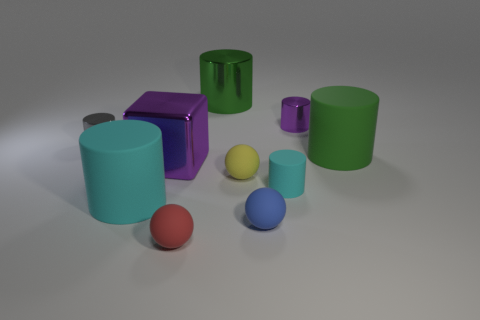Are there more green matte objects in front of the small yellow matte object than large cylinders that are in front of the green shiny cylinder?
Ensure brevity in your answer.  No. There is a metallic object that is to the right of the metal cylinder that is behind the purple object that is behind the big purple shiny block; what size is it?
Ensure brevity in your answer.  Small. Are there any other tiny matte cylinders of the same color as the small rubber cylinder?
Provide a short and direct response. No. What number of large green things are there?
Your answer should be very brief. 2. There is a big cylinder left of the metal block left of the green cylinder behind the small purple cylinder; what is it made of?
Keep it short and to the point. Rubber. Is there a small blue cylinder made of the same material as the large purple block?
Make the answer very short. No. Is the large purple cube made of the same material as the tiny blue sphere?
Provide a short and direct response. No. What number of cylinders are either cyan matte objects or small cyan matte things?
Give a very brief answer. 2. The tiny cylinder that is made of the same material as the small red ball is what color?
Offer a terse response. Cyan. Is the number of large green metal cylinders less than the number of tiny purple blocks?
Ensure brevity in your answer.  No. 